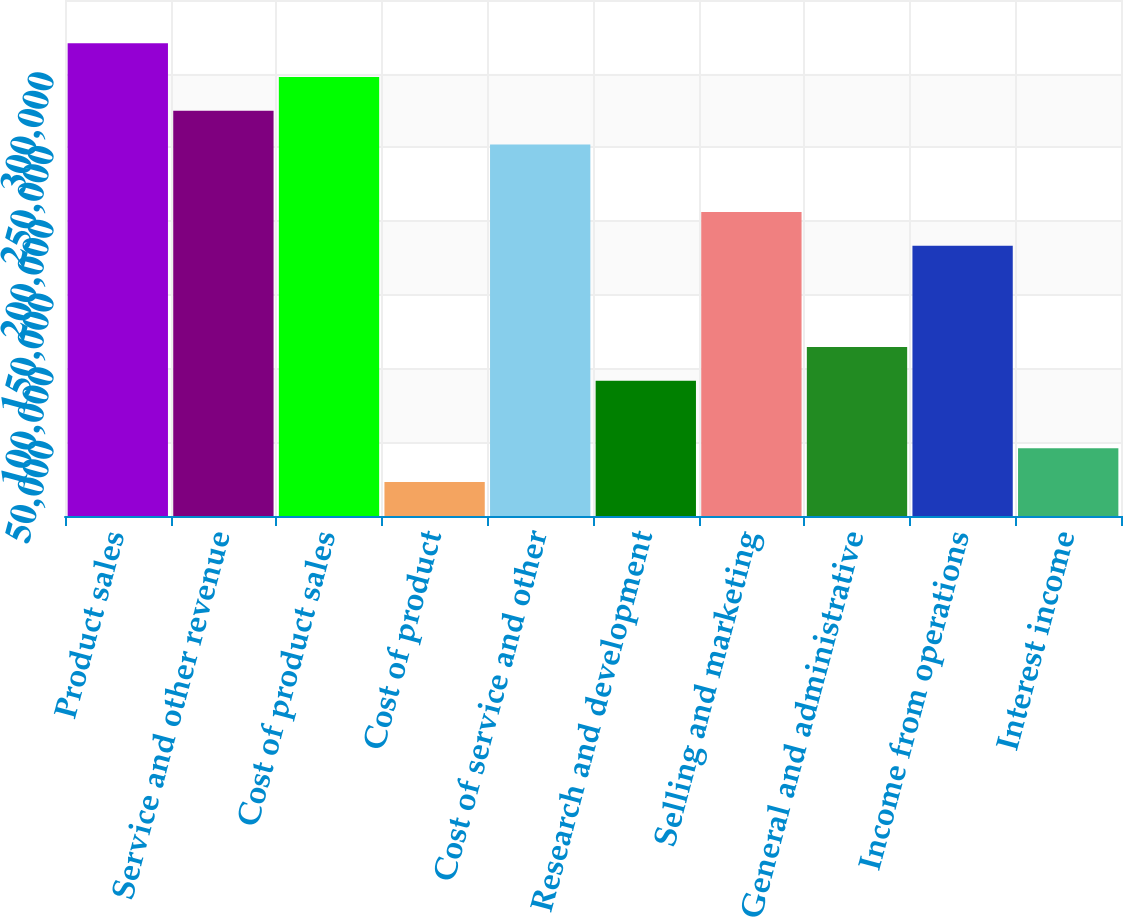Convert chart to OTSL. <chart><loc_0><loc_0><loc_500><loc_500><bar_chart><fcel>Product sales<fcel>Service and other revenue<fcel>Cost of product sales<fcel>Cost of product<fcel>Cost of service and other<fcel>Research and development<fcel>Selling and marketing<fcel>General and administrative<fcel>Income from operations<fcel>Interest income<nl><fcel>320643<fcel>274859<fcel>297751<fcel>23047<fcel>251967<fcel>91723<fcel>206183<fcel>114615<fcel>183291<fcel>45939<nl></chart> 